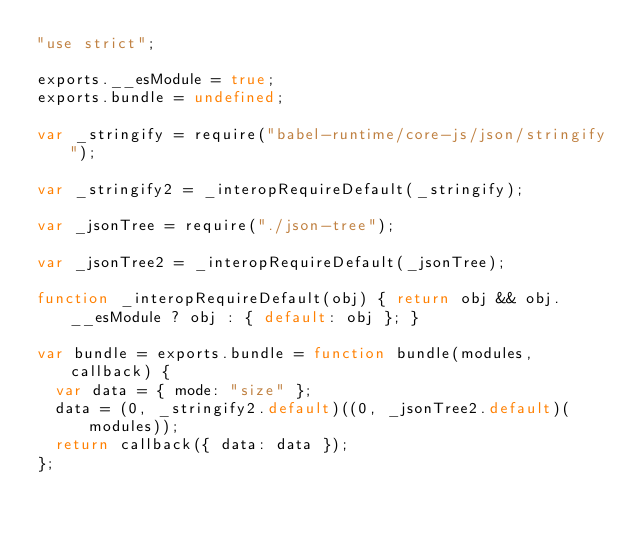Convert code to text. <code><loc_0><loc_0><loc_500><loc_500><_JavaScript_>"use strict";

exports.__esModule = true;
exports.bundle = undefined;

var _stringify = require("babel-runtime/core-js/json/stringify");

var _stringify2 = _interopRequireDefault(_stringify);

var _jsonTree = require("./json-tree");

var _jsonTree2 = _interopRequireDefault(_jsonTree);

function _interopRequireDefault(obj) { return obj && obj.__esModule ? obj : { default: obj }; }

var bundle = exports.bundle = function bundle(modules, callback) {
  var data = { mode: "size" };
  data = (0, _stringify2.default)((0, _jsonTree2.default)(modules));
  return callback({ data: data });
};</code> 